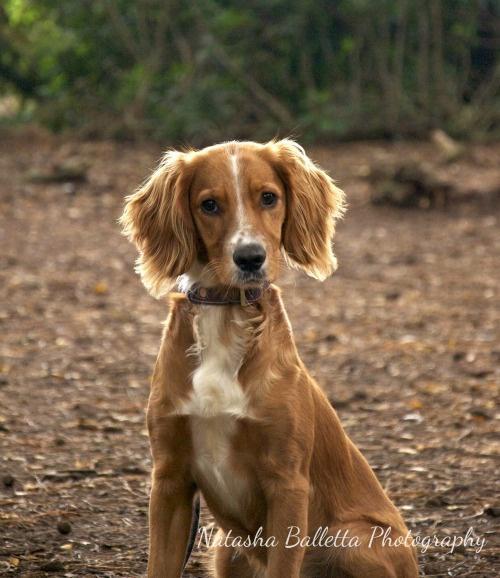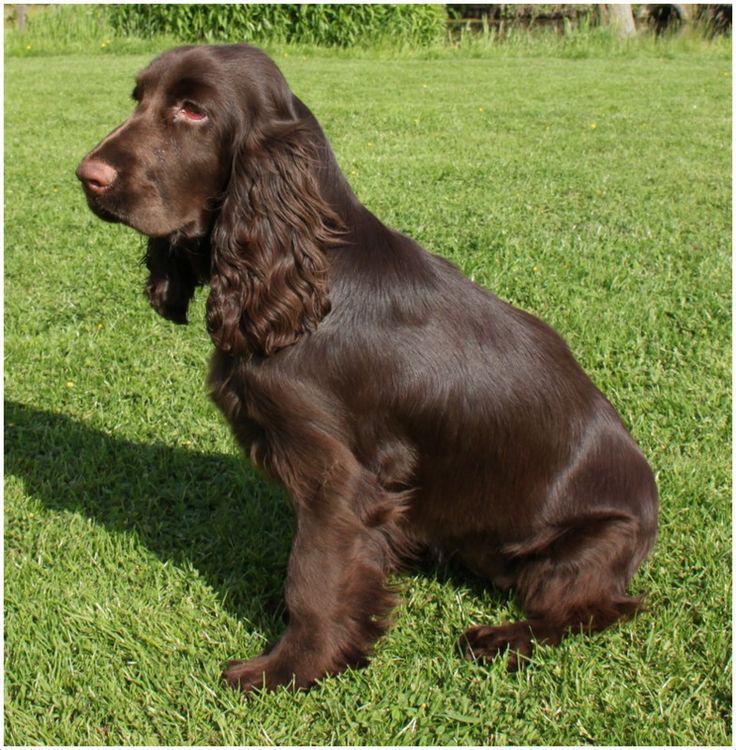The first image is the image on the left, the second image is the image on the right. Analyze the images presented: Is the assertion "One image shows a mostly gold dog sitting upright, and the other shows a dog moving forward over the grass." valid? Answer yes or no. No. The first image is the image on the left, the second image is the image on the right. Given the left and right images, does the statement "The dog in the image on the left is sitting on the grass." hold true? Answer yes or no. No. 